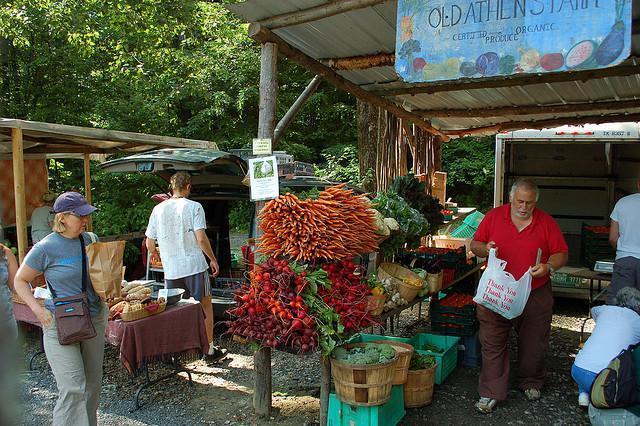How many people are in the picture?
Give a very brief answer. 5. 